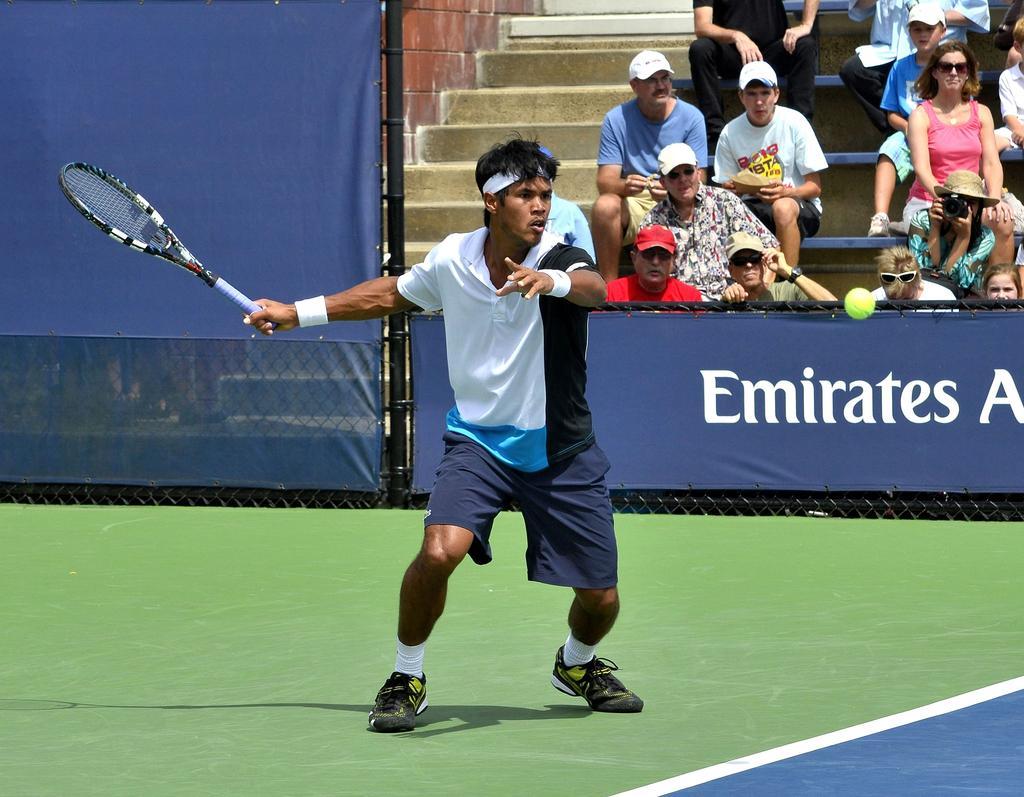How would you summarize this image in a sentence or two? In the image we can see there is a man who is holding tennis racket in his hand and on the other side people are looking at him. 